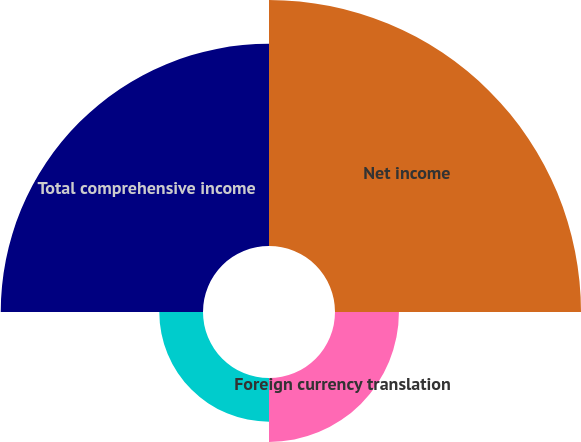<chart> <loc_0><loc_0><loc_500><loc_500><pie_chart><fcel>Net income<fcel>Foreign currency translation<fcel>Total other comprehensive loss<fcel>Total comprehensive income<nl><fcel>44.25%<fcel>11.5%<fcel>7.86%<fcel>36.38%<nl></chart> 